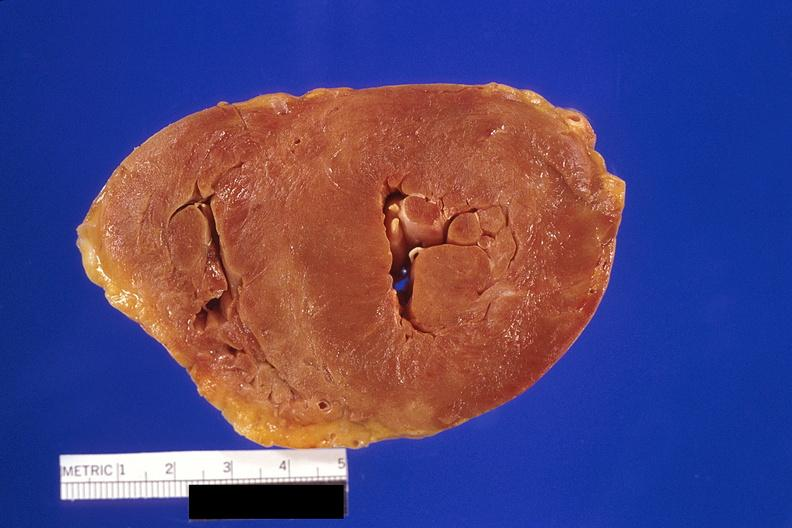s cardiovascular present?
Answer the question using a single word or phrase. Yes 